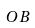<formula> <loc_0><loc_0><loc_500><loc_500>O B</formula> 